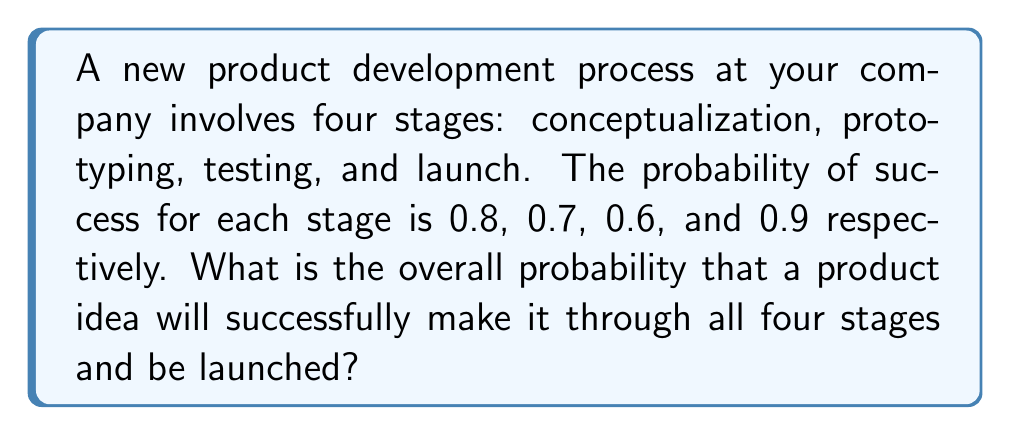Solve this math problem. Let's approach this step-by-step:

1) In this scenario, we have a multi-step process where each step must be successful for the overall process to succeed. This is an example of independent events occurring in sequence.

2) When we have independent events that all need to occur, we multiply the probabilities of each event.

3) Let's define our events:
   A = Successful conceptualization (P(A) = 0.8)
   B = Successful prototyping (P(B) = 0.7)
   C = Successful testing (P(C) = 0.6)
   D = Successful launch (P(D) = 0.9)

4) We want to find P(A and B and C and D)

5) For independent events: P(A and B and C and D) = P(A) × P(B) × P(C) × P(D)

6) Substituting our values:
   P(success) = 0.8 × 0.7 × 0.6 × 0.9

7) Calculating:
   P(success) = 0.3024

Therefore, the probability of a product idea successfully making it through all four stages is 0.3024 or about 30.24%.
Answer: $0.3024$ or $30.24\%$ 